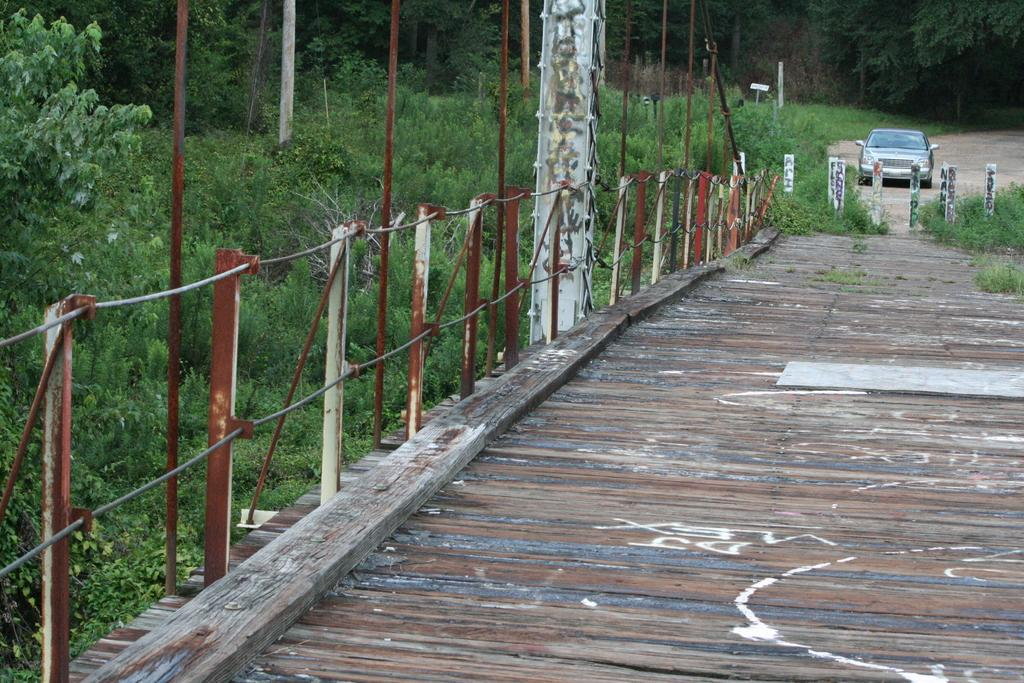What type of structure is present in the image? There is a wooden bridge in the image. What feature does the wooden bridge have? The wooden bridge has railing. What type of vegetation can be seen in the image? There are plants and trees in the image. Is there any transportation visible in the image? Yes, there is a car in the image. Can you hear the plant crying in the image? There is no plant or any sound mentioned in the image, so it is not possible to determine if a plant is crying. 